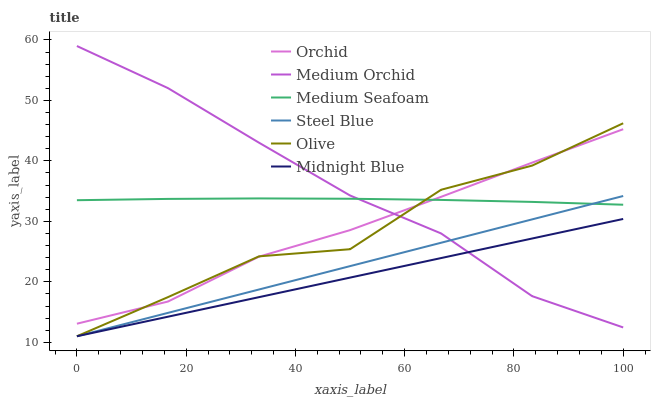Does Midnight Blue have the minimum area under the curve?
Answer yes or no. Yes. Does Medium Orchid have the maximum area under the curve?
Answer yes or no. Yes. Does Steel Blue have the minimum area under the curve?
Answer yes or no. No. Does Steel Blue have the maximum area under the curve?
Answer yes or no. No. Is Midnight Blue the smoothest?
Answer yes or no. Yes. Is Olive the roughest?
Answer yes or no. Yes. Is Medium Orchid the smoothest?
Answer yes or no. No. Is Medium Orchid the roughest?
Answer yes or no. No. Does Midnight Blue have the lowest value?
Answer yes or no. Yes. Does Medium Orchid have the lowest value?
Answer yes or no. No. Does Medium Orchid have the highest value?
Answer yes or no. Yes. Does Steel Blue have the highest value?
Answer yes or no. No. Is Midnight Blue less than Medium Seafoam?
Answer yes or no. Yes. Is Medium Seafoam greater than Midnight Blue?
Answer yes or no. Yes. Does Medium Orchid intersect Midnight Blue?
Answer yes or no. Yes. Is Medium Orchid less than Midnight Blue?
Answer yes or no. No. Is Medium Orchid greater than Midnight Blue?
Answer yes or no. No. Does Midnight Blue intersect Medium Seafoam?
Answer yes or no. No. 